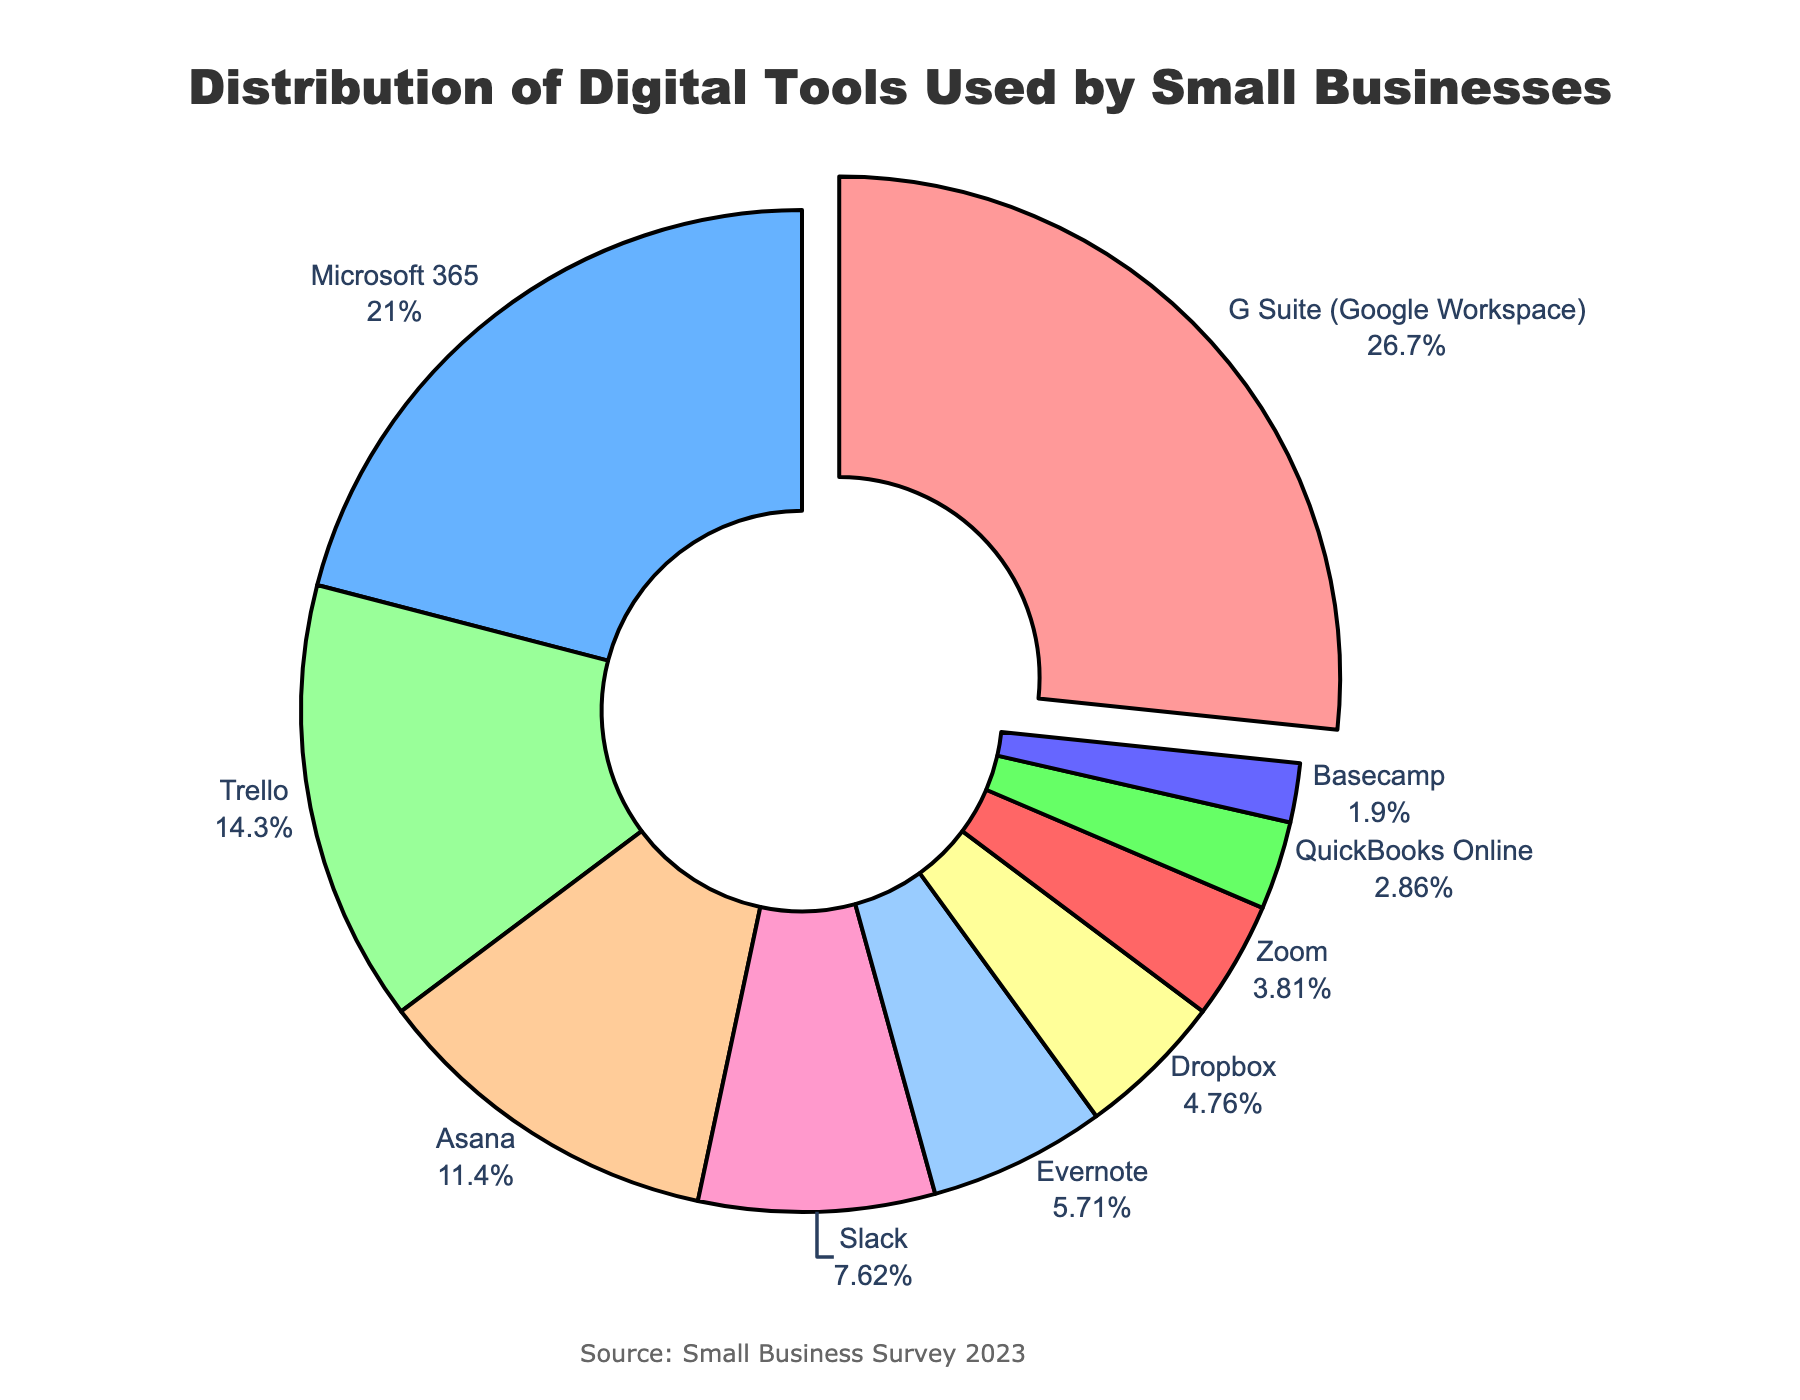What is the most commonly used digital tool by small businesses for organization? The pie chart shows the distribution of various digital tools. The tool with the highest percentage is the most commonly used. G Suite (Google Workspace) is highlighted and has the highest percentage of 28%.
Answer: G Suite (Google Workspace) Which digital tool is used least by small businesses for organization? To determine the least used tool, locate the section with the smallest percentage. Basecamp has the smallest percentage, at 2%.
Answer: Basecamp What is the combined usage percentage of Asana and Slack? Identify the percentages for each tool: Asana has 12% and Slack has 8%. Add them together: 12% + 8% = 20%.
Answer: 20% How does the percentage of Trello users compare to Microsoft 365 users? Trello has 15% and Microsoft 365 has 22%. Comparing these values, Microsoft 365 has a higher percentage.
Answer: Microsoft 365 has a higher percentage What is the total percentage of tools used that have less than 10% each? Identify the tools with less than 10%: Slack (8%), Evernote (6%), Dropbox (5%), Zoom (4%), QuickBooks Online (3%), and Basecamp (2%). Sum these percentages: 8% + 6% + 5% + 4% + 3% + 2% = 28%.
Answer: 28% Which digital tool shares the same color as the slice representing Dropbox? Dropbox is represented by a specific color. Identify the tool with the same color-coded section in the pie chart. Trello and Dropbox share the same color.
Answer: Trello What percentage of small businesses use Trello and QuickBooks Online combined? How does this compare to the percentage of Microsoft 365 users? Trello has 15% and QuickBooks Online has 3%. Their combined usage is 15% + 3% = 18%. Microsoft 365 has 22%. Compare these values: 18% < 22%.
Answer: 18%, less than Microsoft 365 Which tool makes up a larger percentage: Slack or Evernote? Compare the percentages for Slack (8%) and Evernote (6%). Slack has a larger percentage.
Answer: Slack What is the proportion of visually similar colors among uses of Trello, Slack, and Evernote? Look at the visual representation and color code for Trello (green), Slack (pink), and Evernote (cyan). Identify if any two have visually similar colors. None of the colors are visually similar.
Answer: None 